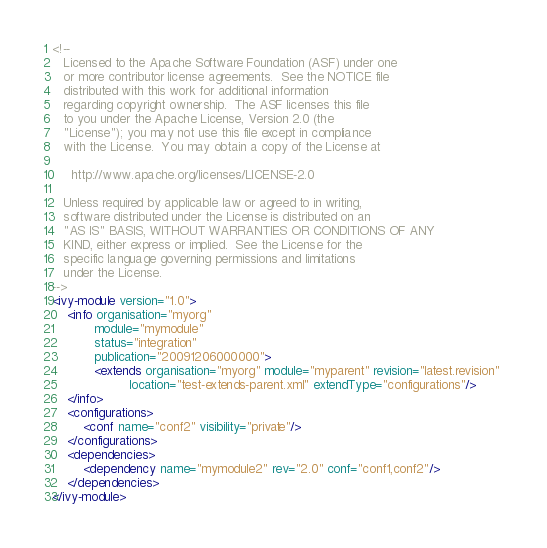Convert code to text. <code><loc_0><loc_0><loc_500><loc_500><_XML_><!--
   Licensed to the Apache Software Foundation (ASF) under one
   or more contributor license agreements.  See the NOTICE file
   distributed with this work for additional information
   regarding copyright ownership.  The ASF licenses this file
   to you under the Apache License, Version 2.0 (the
   "License"); you may not use this file except in compliance
   with the License.  You may obtain a copy of the License at

     http://www.apache.org/licenses/LICENSE-2.0

   Unless required by applicable law or agreed to in writing,
   software distributed under the License is distributed on an
   "AS IS" BASIS, WITHOUT WARRANTIES OR CONDITIONS OF ANY
   KIND, either express or implied.  See the License for the
   specific language governing permissions and limitations
   under the License.    
-->
<ivy-module version="1.0">
	<info organisation="myorg"
	       module="mymodule"
	       status="integration"
	       publication="20091206000000">
	       <extends organisation="myorg" module="myparent" revision="latest.revision" 
	       			location="test-extends-parent.xml" extendType="configurations"/>
	</info>
	<configurations>
		<conf name="conf2" visibility="private"/>
	</configurations>
	<dependencies>
		<dependency name="mymodule2" rev="2.0" conf="conf1,conf2"/>
	</dependencies>
</ivy-module>
</code> 